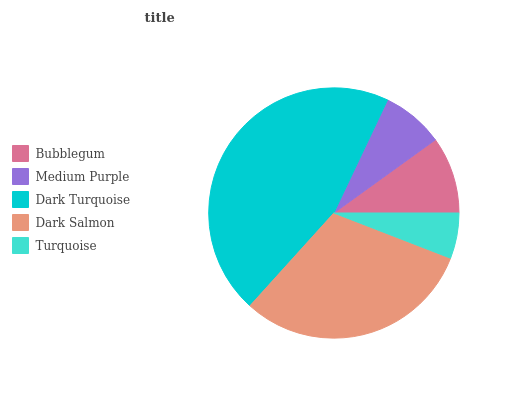Is Turquoise the minimum?
Answer yes or no. Yes. Is Dark Turquoise the maximum?
Answer yes or no. Yes. Is Medium Purple the minimum?
Answer yes or no. No. Is Medium Purple the maximum?
Answer yes or no. No. Is Bubblegum greater than Medium Purple?
Answer yes or no. Yes. Is Medium Purple less than Bubblegum?
Answer yes or no. Yes. Is Medium Purple greater than Bubblegum?
Answer yes or no. No. Is Bubblegum less than Medium Purple?
Answer yes or no. No. Is Bubblegum the high median?
Answer yes or no. Yes. Is Bubblegum the low median?
Answer yes or no. Yes. Is Dark Turquoise the high median?
Answer yes or no. No. Is Dark Salmon the low median?
Answer yes or no. No. 